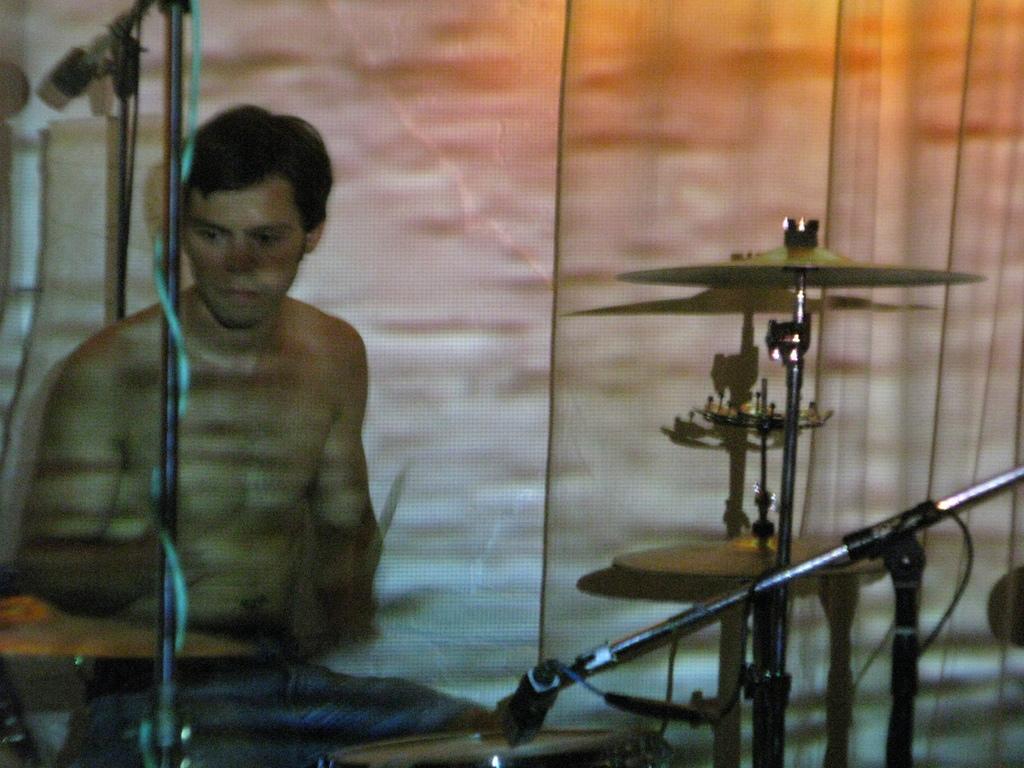Describe this image in one or two sentences. In this picture we can see a man, he is playing drums in front of the microphones. 